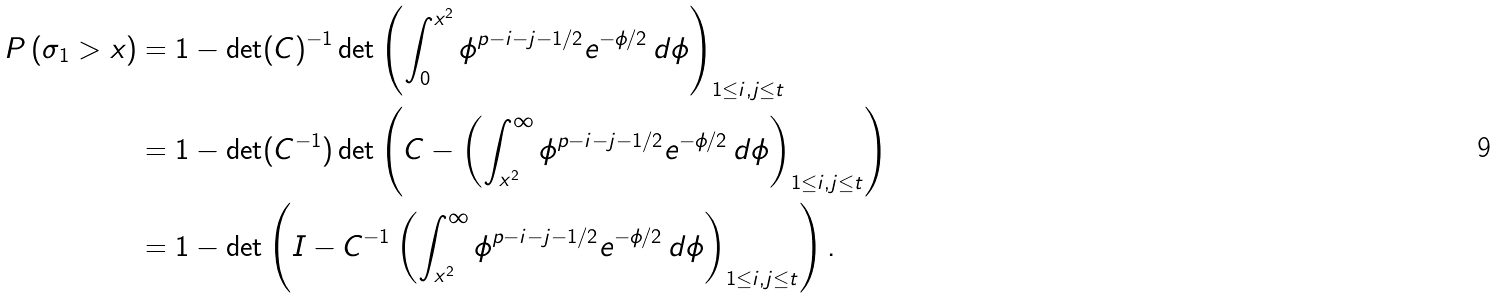Convert formula to latex. <formula><loc_0><loc_0><loc_500><loc_500>P \left ( \sigma _ { 1 } > x \right ) & = 1 - \det ( C ) ^ { - 1 } \det \left ( \int ^ { x ^ { 2 } } _ { 0 } \phi ^ { p - i - j - 1 / 2 } e ^ { - \phi / 2 } \, d \phi \right ) _ { 1 \leq i , j \leq t } \\ & = 1 - \det ( C ^ { - 1 } ) \det \left ( C - \left ( \int _ { x ^ { 2 } } ^ { \infty } \phi ^ { p - i - j - 1 / 2 } e ^ { - \phi / 2 } \, d \phi \right ) _ { 1 \leq i , j \leq t } \right ) \\ & = 1 - \det \left ( I - C ^ { - 1 } \left ( \int _ { x ^ { 2 } } ^ { \infty } \phi ^ { p - i - j - 1 / 2 } e ^ { - \phi / 2 } \, d \phi \right ) _ { 1 \leq i , j \leq t } \right ) .</formula> 